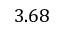<formula> <loc_0><loc_0><loc_500><loc_500>3 . 6 8</formula> 